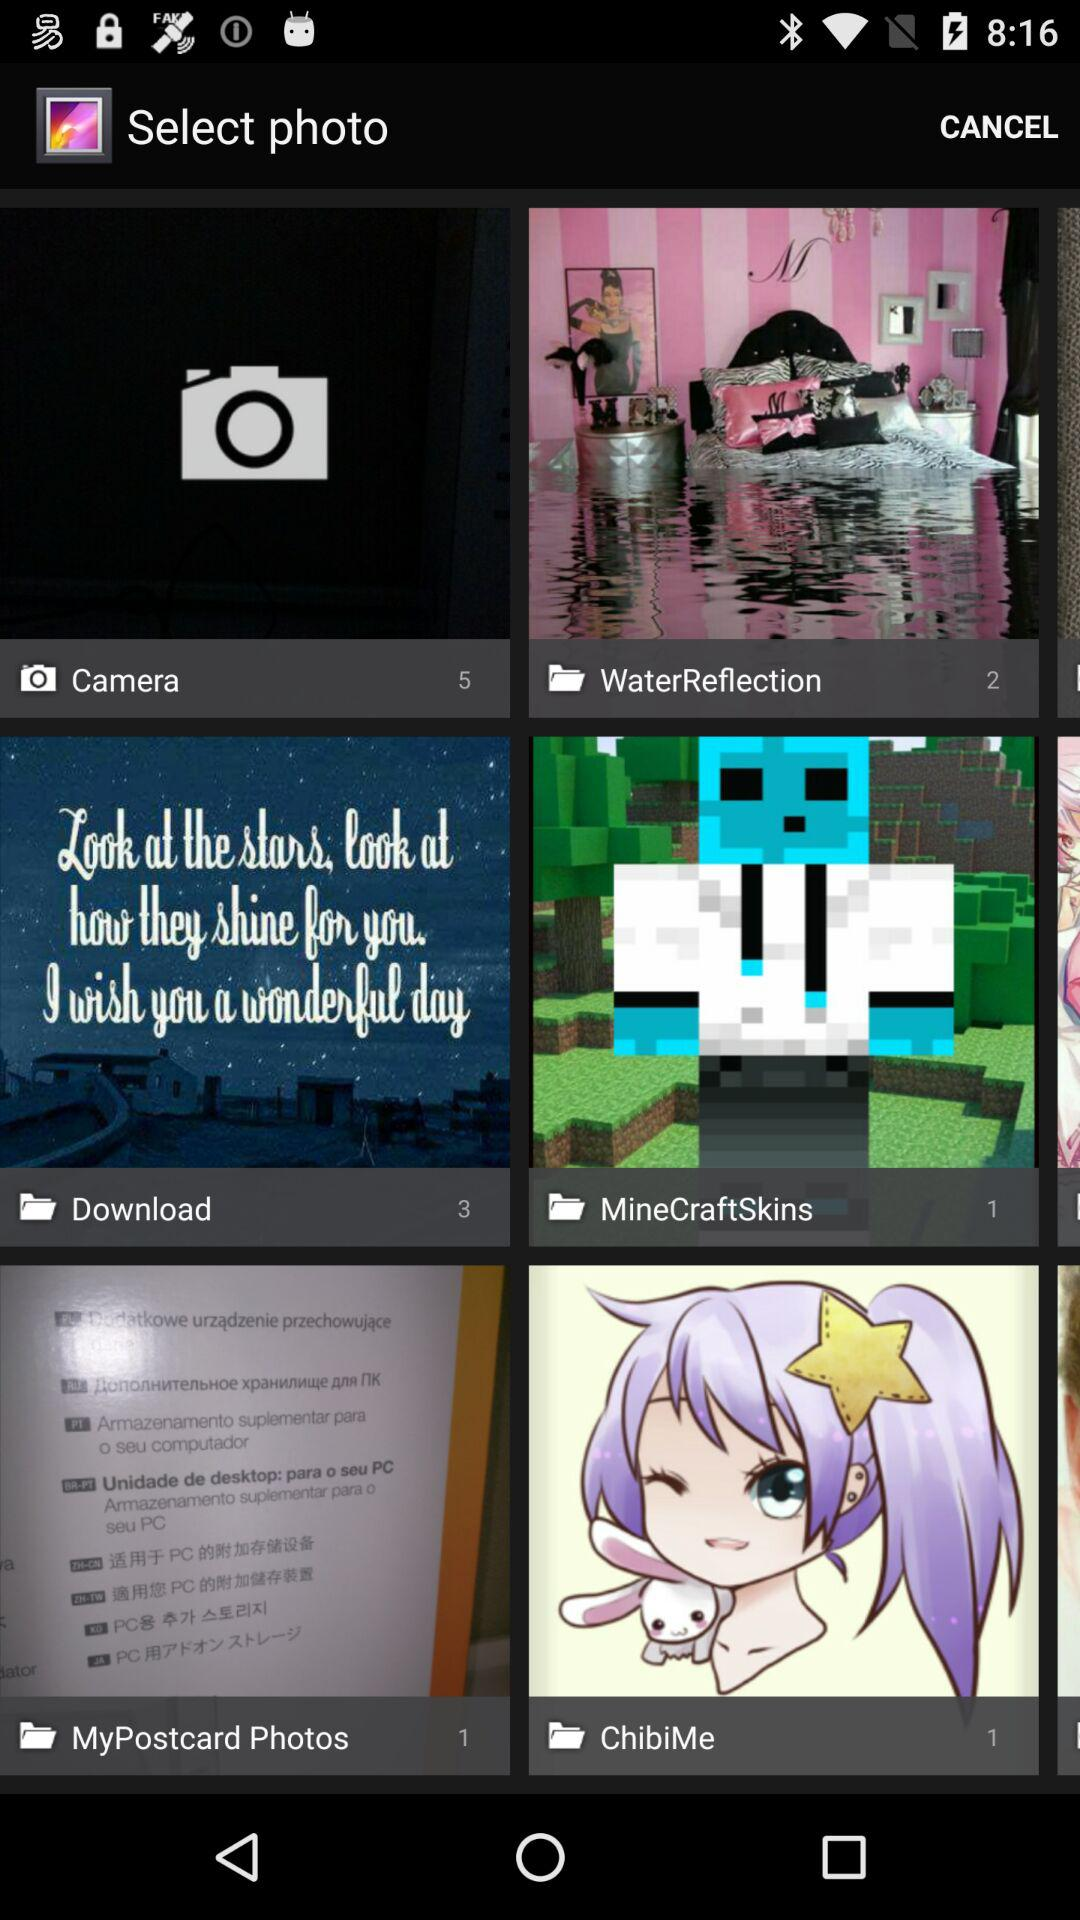What total number of images are there in the "WaterReflection" folder? The total number of images in the "WaterReflection" folder is 2. 